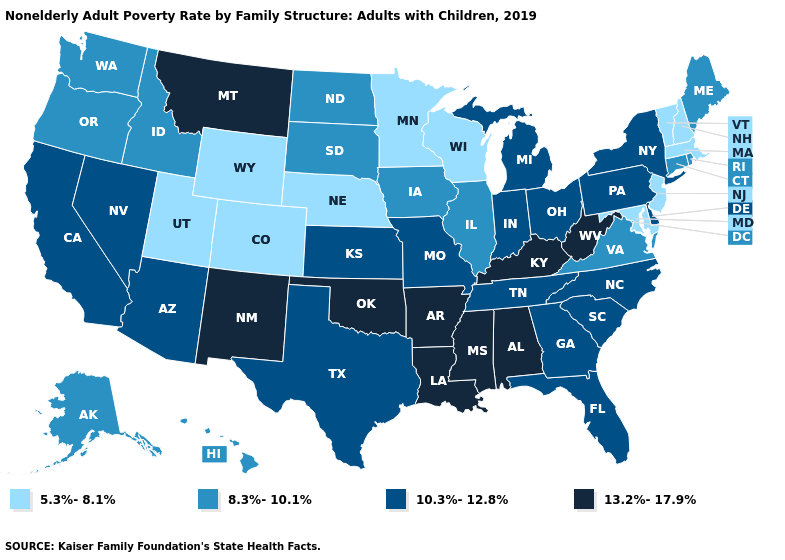Among the states that border Connecticut , which have the highest value?
Write a very short answer. New York. Does Kansas have the same value as Michigan?
Quick response, please. Yes. How many symbols are there in the legend?
Keep it brief. 4. What is the value of California?
Write a very short answer. 10.3%-12.8%. Does the first symbol in the legend represent the smallest category?
Concise answer only. Yes. Name the states that have a value in the range 5.3%-8.1%?
Short answer required. Colorado, Maryland, Massachusetts, Minnesota, Nebraska, New Hampshire, New Jersey, Utah, Vermont, Wisconsin, Wyoming. Which states hav the highest value in the Northeast?
Keep it brief. New York, Pennsylvania. Does Ohio have a higher value than Maryland?
Short answer required. Yes. Which states have the lowest value in the South?
Write a very short answer. Maryland. Name the states that have a value in the range 13.2%-17.9%?
Be succinct. Alabama, Arkansas, Kentucky, Louisiana, Mississippi, Montana, New Mexico, Oklahoma, West Virginia. What is the highest value in the USA?
Give a very brief answer. 13.2%-17.9%. What is the value of Missouri?
Give a very brief answer. 10.3%-12.8%. Does Massachusetts have a higher value than Vermont?
Be succinct. No. What is the value of West Virginia?
Quick response, please. 13.2%-17.9%. What is the highest value in the Northeast ?
Quick response, please. 10.3%-12.8%. 